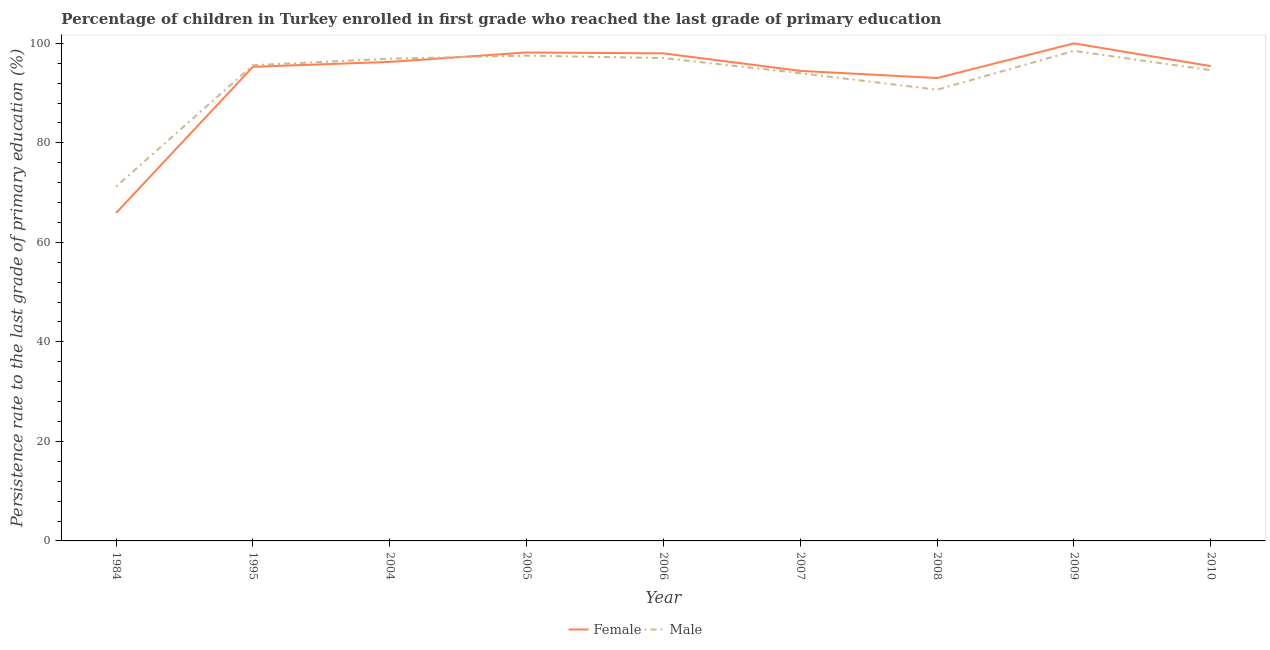What is the persistence rate of male students in 2008?
Provide a succinct answer. 90.68. Across all years, what is the maximum persistence rate of male students?
Your response must be concise. 98.49. Across all years, what is the minimum persistence rate of male students?
Your response must be concise. 71.23. In which year was the persistence rate of male students maximum?
Your response must be concise. 2009. What is the total persistence rate of male students in the graph?
Ensure brevity in your answer.  836.11. What is the difference between the persistence rate of male students in 2005 and that in 2007?
Keep it short and to the point. 3.53. What is the difference between the persistence rate of male students in 2004 and the persistence rate of female students in 2007?
Offer a very short reply. 2.44. What is the average persistence rate of male students per year?
Provide a short and direct response. 92.9. In the year 2010, what is the difference between the persistence rate of male students and persistence rate of female students?
Your response must be concise. -0.82. In how many years, is the persistence rate of male students greater than 32 %?
Your answer should be compact. 9. What is the ratio of the persistence rate of male students in 1995 to that in 2007?
Offer a very short reply. 1.02. What is the difference between the highest and the second highest persistence rate of male students?
Provide a short and direct response. 0.95. What is the difference between the highest and the lowest persistence rate of male students?
Your answer should be very brief. 27.26. Is the sum of the persistence rate of male students in 1984 and 2009 greater than the maximum persistence rate of female students across all years?
Ensure brevity in your answer.  Yes. Does the persistence rate of male students monotonically increase over the years?
Make the answer very short. No. Is the persistence rate of female students strictly greater than the persistence rate of male students over the years?
Provide a short and direct response. No. Is the persistence rate of female students strictly less than the persistence rate of male students over the years?
Provide a short and direct response. No. How many years are there in the graph?
Provide a succinct answer. 9. Are the values on the major ticks of Y-axis written in scientific E-notation?
Your answer should be very brief. No. Does the graph contain any zero values?
Provide a short and direct response. No. How many legend labels are there?
Ensure brevity in your answer.  2. How are the legend labels stacked?
Offer a very short reply. Horizontal. What is the title of the graph?
Your answer should be compact. Percentage of children in Turkey enrolled in first grade who reached the last grade of primary education. Does "Unregistered firms" appear as one of the legend labels in the graph?
Offer a very short reply. No. What is the label or title of the X-axis?
Ensure brevity in your answer.  Year. What is the label or title of the Y-axis?
Your answer should be very brief. Persistence rate to the last grade of primary education (%). What is the Persistence rate to the last grade of primary education (%) of Female in 1984?
Offer a terse response. 65.91. What is the Persistence rate to the last grade of primary education (%) in Male in 1984?
Offer a terse response. 71.23. What is the Persistence rate to the last grade of primary education (%) of Female in 1995?
Your answer should be very brief. 95.29. What is the Persistence rate to the last grade of primary education (%) in Male in 1995?
Give a very brief answer. 95.61. What is the Persistence rate to the last grade of primary education (%) of Female in 2004?
Provide a short and direct response. 96.27. What is the Persistence rate to the last grade of primary education (%) of Male in 2004?
Provide a succinct answer. 96.91. What is the Persistence rate to the last grade of primary education (%) in Female in 2005?
Provide a short and direct response. 98.17. What is the Persistence rate to the last grade of primary education (%) of Male in 2005?
Make the answer very short. 97.53. What is the Persistence rate to the last grade of primary education (%) of Female in 2006?
Your answer should be very brief. 97.99. What is the Persistence rate to the last grade of primary education (%) in Male in 2006?
Offer a terse response. 97.04. What is the Persistence rate to the last grade of primary education (%) of Female in 2007?
Offer a very short reply. 94.47. What is the Persistence rate to the last grade of primary education (%) of Male in 2007?
Offer a terse response. 94. What is the Persistence rate to the last grade of primary education (%) in Female in 2008?
Make the answer very short. 93.03. What is the Persistence rate to the last grade of primary education (%) in Male in 2008?
Provide a succinct answer. 90.68. What is the Persistence rate to the last grade of primary education (%) of Female in 2009?
Your answer should be compact. 100. What is the Persistence rate to the last grade of primary education (%) of Male in 2009?
Offer a terse response. 98.49. What is the Persistence rate to the last grade of primary education (%) in Female in 2010?
Give a very brief answer. 95.43. What is the Persistence rate to the last grade of primary education (%) in Male in 2010?
Keep it short and to the point. 94.61. Across all years, what is the maximum Persistence rate to the last grade of primary education (%) of Female?
Give a very brief answer. 100. Across all years, what is the maximum Persistence rate to the last grade of primary education (%) in Male?
Offer a terse response. 98.49. Across all years, what is the minimum Persistence rate to the last grade of primary education (%) in Female?
Ensure brevity in your answer.  65.91. Across all years, what is the minimum Persistence rate to the last grade of primary education (%) in Male?
Ensure brevity in your answer.  71.23. What is the total Persistence rate to the last grade of primary education (%) in Female in the graph?
Offer a terse response. 836.56. What is the total Persistence rate to the last grade of primary education (%) of Male in the graph?
Your answer should be compact. 836.11. What is the difference between the Persistence rate to the last grade of primary education (%) of Female in 1984 and that in 1995?
Your response must be concise. -29.39. What is the difference between the Persistence rate to the last grade of primary education (%) in Male in 1984 and that in 1995?
Offer a very short reply. -24.37. What is the difference between the Persistence rate to the last grade of primary education (%) in Female in 1984 and that in 2004?
Ensure brevity in your answer.  -30.37. What is the difference between the Persistence rate to the last grade of primary education (%) in Male in 1984 and that in 2004?
Your answer should be compact. -25.68. What is the difference between the Persistence rate to the last grade of primary education (%) of Female in 1984 and that in 2005?
Your answer should be very brief. -32.26. What is the difference between the Persistence rate to the last grade of primary education (%) of Male in 1984 and that in 2005?
Provide a succinct answer. -26.3. What is the difference between the Persistence rate to the last grade of primary education (%) of Female in 1984 and that in 2006?
Your response must be concise. -32.08. What is the difference between the Persistence rate to the last grade of primary education (%) of Male in 1984 and that in 2006?
Your response must be concise. -25.81. What is the difference between the Persistence rate to the last grade of primary education (%) in Female in 1984 and that in 2007?
Make the answer very short. -28.57. What is the difference between the Persistence rate to the last grade of primary education (%) of Male in 1984 and that in 2007?
Your response must be concise. -22.77. What is the difference between the Persistence rate to the last grade of primary education (%) in Female in 1984 and that in 2008?
Offer a very short reply. -27.12. What is the difference between the Persistence rate to the last grade of primary education (%) of Male in 1984 and that in 2008?
Provide a short and direct response. -19.45. What is the difference between the Persistence rate to the last grade of primary education (%) of Female in 1984 and that in 2009?
Make the answer very short. -34.09. What is the difference between the Persistence rate to the last grade of primary education (%) of Male in 1984 and that in 2009?
Provide a succinct answer. -27.26. What is the difference between the Persistence rate to the last grade of primary education (%) in Female in 1984 and that in 2010?
Your answer should be compact. -29.52. What is the difference between the Persistence rate to the last grade of primary education (%) in Male in 1984 and that in 2010?
Your answer should be compact. -23.38. What is the difference between the Persistence rate to the last grade of primary education (%) in Female in 1995 and that in 2004?
Give a very brief answer. -0.98. What is the difference between the Persistence rate to the last grade of primary education (%) in Male in 1995 and that in 2004?
Your response must be concise. -1.31. What is the difference between the Persistence rate to the last grade of primary education (%) in Female in 1995 and that in 2005?
Make the answer very short. -2.87. What is the difference between the Persistence rate to the last grade of primary education (%) of Male in 1995 and that in 2005?
Offer a very short reply. -1.93. What is the difference between the Persistence rate to the last grade of primary education (%) of Female in 1995 and that in 2006?
Ensure brevity in your answer.  -2.7. What is the difference between the Persistence rate to the last grade of primary education (%) in Male in 1995 and that in 2006?
Your response must be concise. -1.44. What is the difference between the Persistence rate to the last grade of primary education (%) in Female in 1995 and that in 2007?
Give a very brief answer. 0.82. What is the difference between the Persistence rate to the last grade of primary education (%) in Male in 1995 and that in 2007?
Ensure brevity in your answer.  1.6. What is the difference between the Persistence rate to the last grade of primary education (%) in Female in 1995 and that in 2008?
Your answer should be very brief. 2.27. What is the difference between the Persistence rate to the last grade of primary education (%) in Male in 1995 and that in 2008?
Your answer should be very brief. 4.92. What is the difference between the Persistence rate to the last grade of primary education (%) of Female in 1995 and that in 2009?
Give a very brief answer. -4.71. What is the difference between the Persistence rate to the last grade of primary education (%) of Male in 1995 and that in 2009?
Your response must be concise. -2.88. What is the difference between the Persistence rate to the last grade of primary education (%) in Female in 1995 and that in 2010?
Your response must be concise. -0.13. What is the difference between the Persistence rate to the last grade of primary education (%) in Male in 1995 and that in 2010?
Your answer should be compact. 1. What is the difference between the Persistence rate to the last grade of primary education (%) in Female in 2004 and that in 2005?
Offer a terse response. -1.89. What is the difference between the Persistence rate to the last grade of primary education (%) of Male in 2004 and that in 2005?
Your answer should be compact. -0.62. What is the difference between the Persistence rate to the last grade of primary education (%) of Female in 2004 and that in 2006?
Offer a very short reply. -1.72. What is the difference between the Persistence rate to the last grade of primary education (%) of Male in 2004 and that in 2006?
Make the answer very short. -0.13. What is the difference between the Persistence rate to the last grade of primary education (%) in Female in 2004 and that in 2007?
Offer a terse response. 1.8. What is the difference between the Persistence rate to the last grade of primary education (%) in Male in 2004 and that in 2007?
Your response must be concise. 2.91. What is the difference between the Persistence rate to the last grade of primary education (%) in Female in 2004 and that in 2008?
Provide a succinct answer. 3.25. What is the difference between the Persistence rate to the last grade of primary education (%) of Male in 2004 and that in 2008?
Your answer should be very brief. 6.23. What is the difference between the Persistence rate to the last grade of primary education (%) in Female in 2004 and that in 2009?
Offer a terse response. -3.73. What is the difference between the Persistence rate to the last grade of primary education (%) in Male in 2004 and that in 2009?
Offer a terse response. -1.57. What is the difference between the Persistence rate to the last grade of primary education (%) of Female in 2004 and that in 2010?
Keep it short and to the point. 0.85. What is the difference between the Persistence rate to the last grade of primary education (%) in Male in 2004 and that in 2010?
Make the answer very short. 2.31. What is the difference between the Persistence rate to the last grade of primary education (%) of Female in 2005 and that in 2006?
Provide a short and direct response. 0.18. What is the difference between the Persistence rate to the last grade of primary education (%) in Male in 2005 and that in 2006?
Provide a succinct answer. 0.49. What is the difference between the Persistence rate to the last grade of primary education (%) in Female in 2005 and that in 2007?
Offer a terse response. 3.69. What is the difference between the Persistence rate to the last grade of primary education (%) of Male in 2005 and that in 2007?
Offer a terse response. 3.53. What is the difference between the Persistence rate to the last grade of primary education (%) of Female in 2005 and that in 2008?
Offer a very short reply. 5.14. What is the difference between the Persistence rate to the last grade of primary education (%) of Male in 2005 and that in 2008?
Your response must be concise. 6.85. What is the difference between the Persistence rate to the last grade of primary education (%) of Female in 2005 and that in 2009?
Keep it short and to the point. -1.83. What is the difference between the Persistence rate to the last grade of primary education (%) of Male in 2005 and that in 2009?
Your response must be concise. -0.95. What is the difference between the Persistence rate to the last grade of primary education (%) in Female in 2005 and that in 2010?
Your response must be concise. 2.74. What is the difference between the Persistence rate to the last grade of primary education (%) of Male in 2005 and that in 2010?
Ensure brevity in your answer.  2.92. What is the difference between the Persistence rate to the last grade of primary education (%) of Female in 2006 and that in 2007?
Your response must be concise. 3.52. What is the difference between the Persistence rate to the last grade of primary education (%) in Male in 2006 and that in 2007?
Your answer should be very brief. 3.04. What is the difference between the Persistence rate to the last grade of primary education (%) of Female in 2006 and that in 2008?
Your answer should be very brief. 4.96. What is the difference between the Persistence rate to the last grade of primary education (%) in Male in 2006 and that in 2008?
Keep it short and to the point. 6.36. What is the difference between the Persistence rate to the last grade of primary education (%) in Female in 2006 and that in 2009?
Your answer should be very brief. -2.01. What is the difference between the Persistence rate to the last grade of primary education (%) of Male in 2006 and that in 2009?
Your answer should be compact. -1.44. What is the difference between the Persistence rate to the last grade of primary education (%) in Female in 2006 and that in 2010?
Your response must be concise. 2.56. What is the difference between the Persistence rate to the last grade of primary education (%) of Male in 2006 and that in 2010?
Offer a very short reply. 2.44. What is the difference between the Persistence rate to the last grade of primary education (%) in Female in 2007 and that in 2008?
Offer a very short reply. 1.45. What is the difference between the Persistence rate to the last grade of primary education (%) in Male in 2007 and that in 2008?
Keep it short and to the point. 3.32. What is the difference between the Persistence rate to the last grade of primary education (%) in Female in 2007 and that in 2009?
Your answer should be compact. -5.53. What is the difference between the Persistence rate to the last grade of primary education (%) in Male in 2007 and that in 2009?
Give a very brief answer. -4.49. What is the difference between the Persistence rate to the last grade of primary education (%) in Female in 2007 and that in 2010?
Your answer should be very brief. -0.95. What is the difference between the Persistence rate to the last grade of primary education (%) in Male in 2007 and that in 2010?
Keep it short and to the point. -0.61. What is the difference between the Persistence rate to the last grade of primary education (%) in Female in 2008 and that in 2009?
Make the answer very short. -6.97. What is the difference between the Persistence rate to the last grade of primary education (%) of Male in 2008 and that in 2009?
Ensure brevity in your answer.  -7.8. What is the difference between the Persistence rate to the last grade of primary education (%) of Female in 2008 and that in 2010?
Ensure brevity in your answer.  -2.4. What is the difference between the Persistence rate to the last grade of primary education (%) in Male in 2008 and that in 2010?
Provide a succinct answer. -3.92. What is the difference between the Persistence rate to the last grade of primary education (%) of Female in 2009 and that in 2010?
Offer a terse response. 4.57. What is the difference between the Persistence rate to the last grade of primary education (%) of Male in 2009 and that in 2010?
Give a very brief answer. 3.88. What is the difference between the Persistence rate to the last grade of primary education (%) in Female in 1984 and the Persistence rate to the last grade of primary education (%) in Male in 1995?
Make the answer very short. -29.7. What is the difference between the Persistence rate to the last grade of primary education (%) of Female in 1984 and the Persistence rate to the last grade of primary education (%) of Male in 2004?
Your response must be concise. -31.01. What is the difference between the Persistence rate to the last grade of primary education (%) in Female in 1984 and the Persistence rate to the last grade of primary education (%) in Male in 2005?
Your answer should be very brief. -31.63. What is the difference between the Persistence rate to the last grade of primary education (%) of Female in 1984 and the Persistence rate to the last grade of primary education (%) of Male in 2006?
Your answer should be very brief. -31.14. What is the difference between the Persistence rate to the last grade of primary education (%) in Female in 1984 and the Persistence rate to the last grade of primary education (%) in Male in 2007?
Your response must be concise. -28.09. What is the difference between the Persistence rate to the last grade of primary education (%) of Female in 1984 and the Persistence rate to the last grade of primary education (%) of Male in 2008?
Make the answer very short. -24.78. What is the difference between the Persistence rate to the last grade of primary education (%) in Female in 1984 and the Persistence rate to the last grade of primary education (%) in Male in 2009?
Keep it short and to the point. -32.58. What is the difference between the Persistence rate to the last grade of primary education (%) in Female in 1984 and the Persistence rate to the last grade of primary education (%) in Male in 2010?
Keep it short and to the point. -28.7. What is the difference between the Persistence rate to the last grade of primary education (%) of Female in 1995 and the Persistence rate to the last grade of primary education (%) of Male in 2004?
Ensure brevity in your answer.  -1.62. What is the difference between the Persistence rate to the last grade of primary education (%) in Female in 1995 and the Persistence rate to the last grade of primary education (%) in Male in 2005?
Offer a very short reply. -2.24. What is the difference between the Persistence rate to the last grade of primary education (%) of Female in 1995 and the Persistence rate to the last grade of primary education (%) of Male in 2006?
Keep it short and to the point. -1.75. What is the difference between the Persistence rate to the last grade of primary education (%) of Female in 1995 and the Persistence rate to the last grade of primary education (%) of Male in 2007?
Give a very brief answer. 1.29. What is the difference between the Persistence rate to the last grade of primary education (%) of Female in 1995 and the Persistence rate to the last grade of primary education (%) of Male in 2008?
Offer a very short reply. 4.61. What is the difference between the Persistence rate to the last grade of primary education (%) of Female in 1995 and the Persistence rate to the last grade of primary education (%) of Male in 2009?
Ensure brevity in your answer.  -3.19. What is the difference between the Persistence rate to the last grade of primary education (%) of Female in 1995 and the Persistence rate to the last grade of primary education (%) of Male in 2010?
Keep it short and to the point. 0.69. What is the difference between the Persistence rate to the last grade of primary education (%) of Female in 2004 and the Persistence rate to the last grade of primary education (%) of Male in 2005?
Your response must be concise. -1.26. What is the difference between the Persistence rate to the last grade of primary education (%) in Female in 2004 and the Persistence rate to the last grade of primary education (%) in Male in 2006?
Offer a terse response. -0.77. What is the difference between the Persistence rate to the last grade of primary education (%) of Female in 2004 and the Persistence rate to the last grade of primary education (%) of Male in 2007?
Make the answer very short. 2.27. What is the difference between the Persistence rate to the last grade of primary education (%) in Female in 2004 and the Persistence rate to the last grade of primary education (%) in Male in 2008?
Provide a succinct answer. 5.59. What is the difference between the Persistence rate to the last grade of primary education (%) in Female in 2004 and the Persistence rate to the last grade of primary education (%) in Male in 2009?
Keep it short and to the point. -2.21. What is the difference between the Persistence rate to the last grade of primary education (%) of Female in 2004 and the Persistence rate to the last grade of primary education (%) of Male in 2010?
Your answer should be very brief. 1.67. What is the difference between the Persistence rate to the last grade of primary education (%) in Female in 2005 and the Persistence rate to the last grade of primary education (%) in Male in 2006?
Your answer should be very brief. 1.12. What is the difference between the Persistence rate to the last grade of primary education (%) in Female in 2005 and the Persistence rate to the last grade of primary education (%) in Male in 2007?
Provide a succinct answer. 4.17. What is the difference between the Persistence rate to the last grade of primary education (%) of Female in 2005 and the Persistence rate to the last grade of primary education (%) of Male in 2008?
Your answer should be compact. 7.48. What is the difference between the Persistence rate to the last grade of primary education (%) of Female in 2005 and the Persistence rate to the last grade of primary education (%) of Male in 2009?
Ensure brevity in your answer.  -0.32. What is the difference between the Persistence rate to the last grade of primary education (%) of Female in 2005 and the Persistence rate to the last grade of primary education (%) of Male in 2010?
Your answer should be compact. 3.56. What is the difference between the Persistence rate to the last grade of primary education (%) in Female in 2006 and the Persistence rate to the last grade of primary education (%) in Male in 2007?
Provide a short and direct response. 3.99. What is the difference between the Persistence rate to the last grade of primary education (%) of Female in 2006 and the Persistence rate to the last grade of primary education (%) of Male in 2008?
Make the answer very short. 7.31. What is the difference between the Persistence rate to the last grade of primary education (%) in Female in 2006 and the Persistence rate to the last grade of primary education (%) in Male in 2009?
Provide a succinct answer. -0.5. What is the difference between the Persistence rate to the last grade of primary education (%) of Female in 2006 and the Persistence rate to the last grade of primary education (%) of Male in 2010?
Your answer should be compact. 3.38. What is the difference between the Persistence rate to the last grade of primary education (%) of Female in 2007 and the Persistence rate to the last grade of primary education (%) of Male in 2008?
Keep it short and to the point. 3.79. What is the difference between the Persistence rate to the last grade of primary education (%) in Female in 2007 and the Persistence rate to the last grade of primary education (%) in Male in 2009?
Offer a terse response. -4.01. What is the difference between the Persistence rate to the last grade of primary education (%) of Female in 2007 and the Persistence rate to the last grade of primary education (%) of Male in 2010?
Provide a short and direct response. -0.13. What is the difference between the Persistence rate to the last grade of primary education (%) in Female in 2008 and the Persistence rate to the last grade of primary education (%) in Male in 2009?
Keep it short and to the point. -5.46. What is the difference between the Persistence rate to the last grade of primary education (%) in Female in 2008 and the Persistence rate to the last grade of primary education (%) in Male in 2010?
Your answer should be compact. -1.58. What is the difference between the Persistence rate to the last grade of primary education (%) of Female in 2009 and the Persistence rate to the last grade of primary education (%) of Male in 2010?
Provide a short and direct response. 5.39. What is the average Persistence rate to the last grade of primary education (%) of Female per year?
Provide a short and direct response. 92.95. What is the average Persistence rate to the last grade of primary education (%) of Male per year?
Your response must be concise. 92.9. In the year 1984, what is the difference between the Persistence rate to the last grade of primary education (%) in Female and Persistence rate to the last grade of primary education (%) in Male?
Give a very brief answer. -5.32. In the year 1995, what is the difference between the Persistence rate to the last grade of primary education (%) in Female and Persistence rate to the last grade of primary education (%) in Male?
Offer a terse response. -0.31. In the year 2004, what is the difference between the Persistence rate to the last grade of primary education (%) in Female and Persistence rate to the last grade of primary education (%) in Male?
Keep it short and to the point. -0.64. In the year 2005, what is the difference between the Persistence rate to the last grade of primary education (%) of Female and Persistence rate to the last grade of primary education (%) of Male?
Keep it short and to the point. 0.64. In the year 2006, what is the difference between the Persistence rate to the last grade of primary education (%) in Female and Persistence rate to the last grade of primary education (%) in Male?
Provide a short and direct response. 0.95. In the year 2007, what is the difference between the Persistence rate to the last grade of primary education (%) of Female and Persistence rate to the last grade of primary education (%) of Male?
Make the answer very short. 0.47. In the year 2008, what is the difference between the Persistence rate to the last grade of primary education (%) of Female and Persistence rate to the last grade of primary education (%) of Male?
Your response must be concise. 2.34. In the year 2009, what is the difference between the Persistence rate to the last grade of primary education (%) of Female and Persistence rate to the last grade of primary education (%) of Male?
Your answer should be compact. 1.51. In the year 2010, what is the difference between the Persistence rate to the last grade of primary education (%) of Female and Persistence rate to the last grade of primary education (%) of Male?
Offer a terse response. 0.82. What is the ratio of the Persistence rate to the last grade of primary education (%) of Female in 1984 to that in 1995?
Ensure brevity in your answer.  0.69. What is the ratio of the Persistence rate to the last grade of primary education (%) in Male in 1984 to that in 1995?
Your answer should be compact. 0.75. What is the ratio of the Persistence rate to the last grade of primary education (%) of Female in 1984 to that in 2004?
Ensure brevity in your answer.  0.68. What is the ratio of the Persistence rate to the last grade of primary education (%) in Male in 1984 to that in 2004?
Offer a terse response. 0.73. What is the ratio of the Persistence rate to the last grade of primary education (%) of Female in 1984 to that in 2005?
Make the answer very short. 0.67. What is the ratio of the Persistence rate to the last grade of primary education (%) in Male in 1984 to that in 2005?
Provide a succinct answer. 0.73. What is the ratio of the Persistence rate to the last grade of primary education (%) in Female in 1984 to that in 2006?
Provide a short and direct response. 0.67. What is the ratio of the Persistence rate to the last grade of primary education (%) of Male in 1984 to that in 2006?
Your answer should be compact. 0.73. What is the ratio of the Persistence rate to the last grade of primary education (%) of Female in 1984 to that in 2007?
Provide a succinct answer. 0.7. What is the ratio of the Persistence rate to the last grade of primary education (%) in Male in 1984 to that in 2007?
Your answer should be very brief. 0.76. What is the ratio of the Persistence rate to the last grade of primary education (%) in Female in 1984 to that in 2008?
Keep it short and to the point. 0.71. What is the ratio of the Persistence rate to the last grade of primary education (%) in Male in 1984 to that in 2008?
Provide a succinct answer. 0.79. What is the ratio of the Persistence rate to the last grade of primary education (%) of Female in 1984 to that in 2009?
Your answer should be very brief. 0.66. What is the ratio of the Persistence rate to the last grade of primary education (%) of Male in 1984 to that in 2009?
Provide a short and direct response. 0.72. What is the ratio of the Persistence rate to the last grade of primary education (%) of Female in 1984 to that in 2010?
Your answer should be compact. 0.69. What is the ratio of the Persistence rate to the last grade of primary education (%) in Male in 1984 to that in 2010?
Ensure brevity in your answer.  0.75. What is the ratio of the Persistence rate to the last grade of primary education (%) of Female in 1995 to that in 2004?
Your answer should be very brief. 0.99. What is the ratio of the Persistence rate to the last grade of primary education (%) of Male in 1995 to that in 2004?
Keep it short and to the point. 0.99. What is the ratio of the Persistence rate to the last grade of primary education (%) of Female in 1995 to that in 2005?
Offer a terse response. 0.97. What is the ratio of the Persistence rate to the last grade of primary education (%) of Male in 1995 to that in 2005?
Provide a short and direct response. 0.98. What is the ratio of the Persistence rate to the last grade of primary education (%) in Female in 1995 to that in 2006?
Your response must be concise. 0.97. What is the ratio of the Persistence rate to the last grade of primary education (%) in Male in 1995 to that in 2006?
Your response must be concise. 0.99. What is the ratio of the Persistence rate to the last grade of primary education (%) in Female in 1995 to that in 2007?
Ensure brevity in your answer.  1.01. What is the ratio of the Persistence rate to the last grade of primary education (%) of Male in 1995 to that in 2007?
Your answer should be very brief. 1.02. What is the ratio of the Persistence rate to the last grade of primary education (%) of Female in 1995 to that in 2008?
Your answer should be very brief. 1.02. What is the ratio of the Persistence rate to the last grade of primary education (%) in Male in 1995 to that in 2008?
Your response must be concise. 1.05. What is the ratio of the Persistence rate to the last grade of primary education (%) of Female in 1995 to that in 2009?
Your answer should be very brief. 0.95. What is the ratio of the Persistence rate to the last grade of primary education (%) in Male in 1995 to that in 2009?
Provide a short and direct response. 0.97. What is the ratio of the Persistence rate to the last grade of primary education (%) of Female in 1995 to that in 2010?
Make the answer very short. 1. What is the ratio of the Persistence rate to the last grade of primary education (%) in Male in 1995 to that in 2010?
Provide a short and direct response. 1.01. What is the ratio of the Persistence rate to the last grade of primary education (%) of Female in 2004 to that in 2005?
Offer a terse response. 0.98. What is the ratio of the Persistence rate to the last grade of primary education (%) of Male in 2004 to that in 2005?
Your answer should be compact. 0.99. What is the ratio of the Persistence rate to the last grade of primary education (%) of Female in 2004 to that in 2006?
Your answer should be very brief. 0.98. What is the ratio of the Persistence rate to the last grade of primary education (%) in Female in 2004 to that in 2007?
Offer a terse response. 1.02. What is the ratio of the Persistence rate to the last grade of primary education (%) in Male in 2004 to that in 2007?
Ensure brevity in your answer.  1.03. What is the ratio of the Persistence rate to the last grade of primary education (%) in Female in 2004 to that in 2008?
Make the answer very short. 1.03. What is the ratio of the Persistence rate to the last grade of primary education (%) of Male in 2004 to that in 2008?
Keep it short and to the point. 1.07. What is the ratio of the Persistence rate to the last grade of primary education (%) of Female in 2004 to that in 2009?
Ensure brevity in your answer.  0.96. What is the ratio of the Persistence rate to the last grade of primary education (%) in Female in 2004 to that in 2010?
Keep it short and to the point. 1.01. What is the ratio of the Persistence rate to the last grade of primary education (%) of Male in 2004 to that in 2010?
Make the answer very short. 1.02. What is the ratio of the Persistence rate to the last grade of primary education (%) in Female in 2005 to that in 2006?
Offer a terse response. 1. What is the ratio of the Persistence rate to the last grade of primary education (%) of Male in 2005 to that in 2006?
Provide a succinct answer. 1. What is the ratio of the Persistence rate to the last grade of primary education (%) in Female in 2005 to that in 2007?
Ensure brevity in your answer.  1.04. What is the ratio of the Persistence rate to the last grade of primary education (%) of Male in 2005 to that in 2007?
Make the answer very short. 1.04. What is the ratio of the Persistence rate to the last grade of primary education (%) in Female in 2005 to that in 2008?
Offer a terse response. 1.06. What is the ratio of the Persistence rate to the last grade of primary education (%) of Male in 2005 to that in 2008?
Offer a very short reply. 1.08. What is the ratio of the Persistence rate to the last grade of primary education (%) of Female in 2005 to that in 2009?
Provide a short and direct response. 0.98. What is the ratio of the Persistence rate to the last grade of primary education (%) of Male in 2005 to that in 2009?
Your response must be concise. 0.99. What is the ratio of the Persistence rate to the last grade of primary education (%) in Female in 2005 to that in 2010?
Offer a very short reply. 1.03. What is the ratio of the Persistence rate to the last grade of primary education (%) of Male in 2005 to that in 2010?
Offer a very short reply. 1.03. What is the ratio of the Persistence rate to the last grade of primary education (%) in Female in 2006 to that in 2007?
Offer a very short reply. 1.04. What is the ratio of the Persistence rate to the last grade of primary education (%) of Male in 2006 to that in 2007?
Make the answer very short. 1.03. What is the ratio of the Persistence rate to the last grade of primary education (%) in Female in 2006 to that in 2008?
Offer a terse response. 1.05. What is the ratio of the Persistence rate to the last grade of primary education (%) of Male in 2006 to that in 2008?
Make the answer very short. 1.07. What is the ratio of the Persistence rate to the last grade of primary education (%) in Female in 2006 to that in 2009?
Your answer should be compact. 0.98. What is the ratio of the Persistence rate to the last grade of primary education (%) of Female in 2006 to that in 2010?
Ensure brevity in your answer.  1.03. What is the ratio of the Persistence rate to the last grade of primary education (%) of Male in 2006 to that in 2010?
Your answer should be compact. 1.03. What is the ratio of the Persistence rate to the last grade of primary education (%) in Female in 2007 to that in 2008?
Offer a terse response. 1.02. What is the ratio of the Persistence rate to the last grade of primary education (%) in Male in 2007 to that in 2008?
Your response must be concise. 1.04. What is the ratio of the Persistence rate to the last grade of primary education (%) in Female in 2007 to that in 2009?
Keep it short and to the point. 0.94. What is the ratio of the Persistence rate to the last grade of primary education (%) in Male in 2007 to that in 2009?
Keep it short and to the point. 0.95. What is the ratio of the Persistence rate to the last grade of primary education (%) in Female in 2007 to that in 2010?
Make the answer very short. 0.99. What is the ratio of the Persistence rate to the last grade of primary education (%) of Female in 2008 to that in 2009?
Keep it short and to the point. 0.93. What is the ratio of the Persistence rate to the last grade of primary education (%) of Male in 2008 to that in 2009?
Give a very brief answer. 0.92. What is the ratio of the Persistence rate to the last grade of primary education (%) in Female in 2008 to that in 2010?
Offer a terse response. 0.97. What is the ratio of the Persistence rate to the last grade of primary education (%) in Male in 2008 to that in 2010?
Ensure brevity in your answer.  0.96. What is the ratio of the Persistence rate to the last grade of primary education (%) in Female in 2009 to that in 2010?
Ensure brevity in your answer.  1.05. What is the ratio of the Persistence rate to the last grade of primary education (%) in Male in 2009 to that in 2010?
Your response must be concise. 1.04. What is the difference between the highest and the second highest Persistence rate to the last grade of primary education (%) in Female?
Offer a very short reply. 1.83. What is the difference between the highest and the second highest Persistence rate to the last grade of primary education (%) in Male?
Make the answer very short. 0.95. What is the difference between the highest and the lowest Persistence rate to the last grade of primary education (%) in Female?
Your answer should be very brief. 34.09. What is the difference between the highest and the lowest Persistence rate to the last grade of primary education (%) of Male?
Keep it short and to the point. 27.26. 